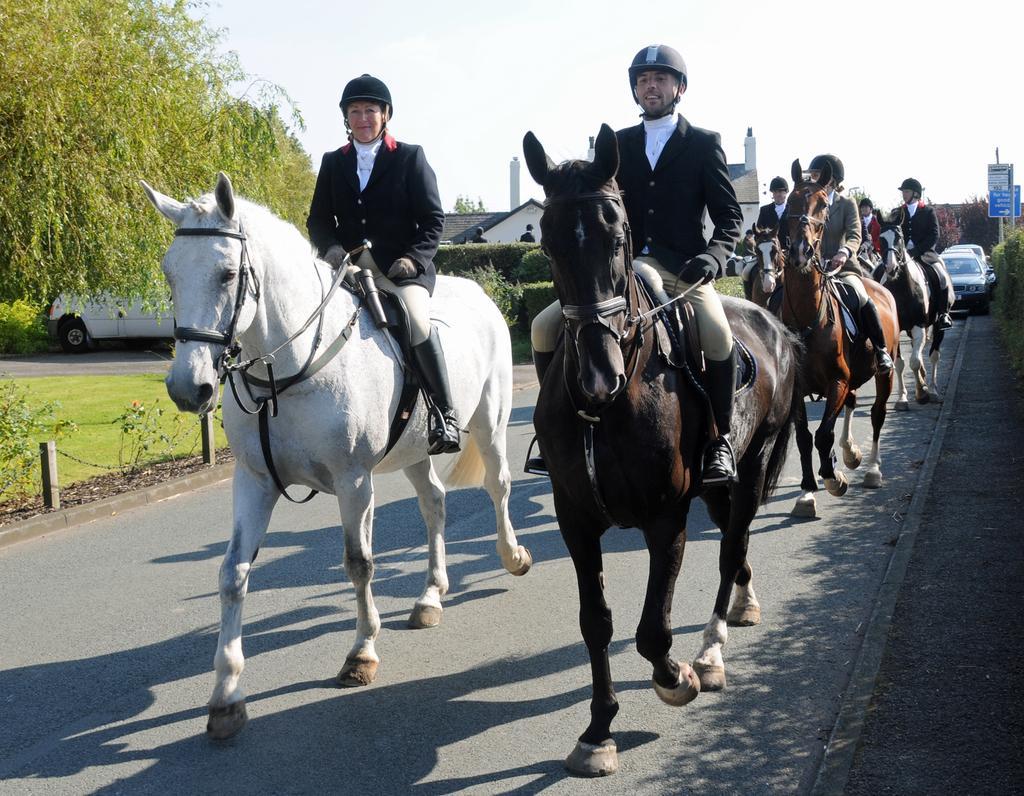Describe this image in one or two sentences. In this image there is a group of persons are riding the horse, as we can see in middle of this image , and there is a house in the background. There are some cars on the right side of this image. there is a tree on the left side of this image, there is one car is behind to this tree. There is a road on the bottom of this image and there is a sky on the top of this image. 